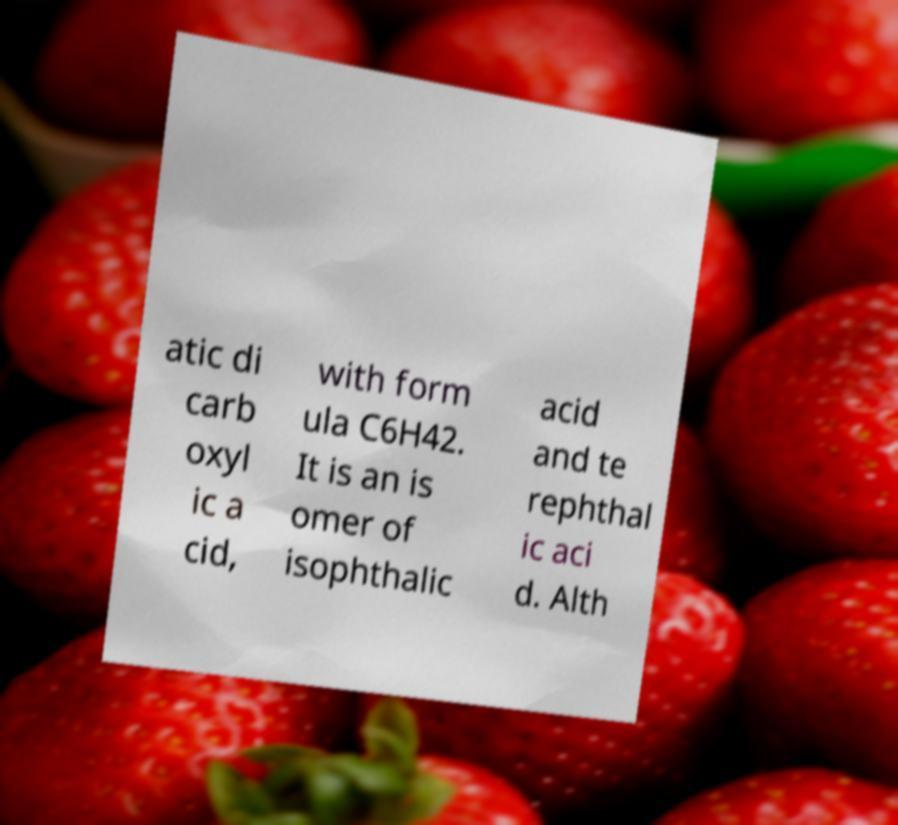For documentation purposes, I need the text within this image transcribed. Could you provide that? atic di carb oxyl ic a cid, with form ula C6H42. It is an is omer of isophthalic acid and te rephthal ic aci d. Alth 